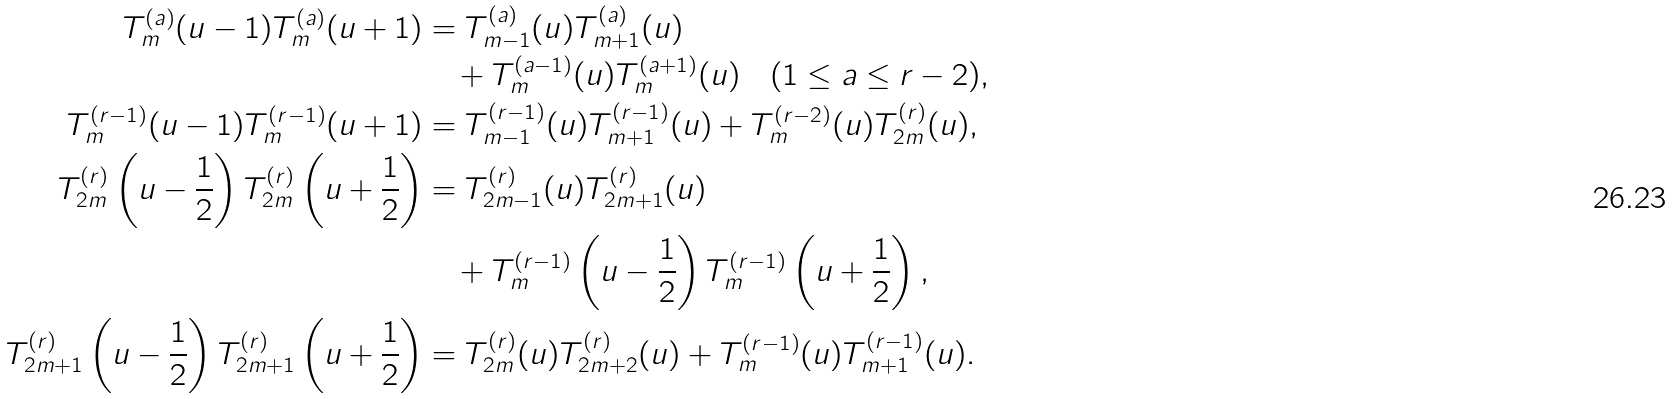<formula> <loc_0><loc_0><loc_500><loc_500>T ^ { ( a ) } _ { m } ( u - 1 ) T ^ { ( a ) } _ { m } ( u + 1 ) & = T ^ { ( a ) } _ { m - 1 } ( u ) T ^ { ( a ) } _ { m + 1 } ( u ) \\ & \quad + T ^ { ( a - 1 ) } _ { m } ( u ) T ^ { ( a + 1 ) } _ { m } ( u ) \quad ( 1 \leq a \leq r - 2 ) , \\ T ^ { ( r - 1 ) } _ { m } ( u - 1 ) T ^ { ( r - 1 ) } _ { m } ( u + 1 ) & = T ^ { ( r - 1 ) } _ { m - 1 } ( u ) T ^ { ( r - 1 ) } _ { m + 1 } ( u ) + T ^ { ( r - 2 ) } _ { m } ( u ) T ^ { ( r ) } _ { 2 m } ( u ) , \\ T ^ { ( r ) } _ { 2 m } \left ( u - \frac { 1 } { 2 } \right ) T ^ { ( r ) } _ { 2 m } \left ( u + \frac { 1 } { 2 } \right ) & = T ^ { ( r ) } _ { 2 m - 1 } ( u ) T ^ { ( r ) } _ { 2 m + 1 } ( u ) \\ & \quad + T ^ { ( r - 1 ) } _ { m } \left ( u - \frac { 1 } { 2 } \right ) T ^ { ( r - 1 ) } _ { m } \left ( u + \frac { 1 } { 2 } \right ) , \\ T ^ { ( r ) } _ { 2 m + 1 } \left ( u - \frac { 1 } { 2 } \right ) T ^ { ( r ) } _ { 2 m + 1 } \left ( u + \frac { 1 } { 2 } \right ) & = T ^ { ( r ) } _ { 2 m } ( u ) T ^ { ( r ) } _ { 2 m + 2 } ( u ) + T ^ { ( r - 1 ) } _ { m } ( u ) T ^ { ( r - 1 ) } _ { m + 1 } ( u ) .</formula> 